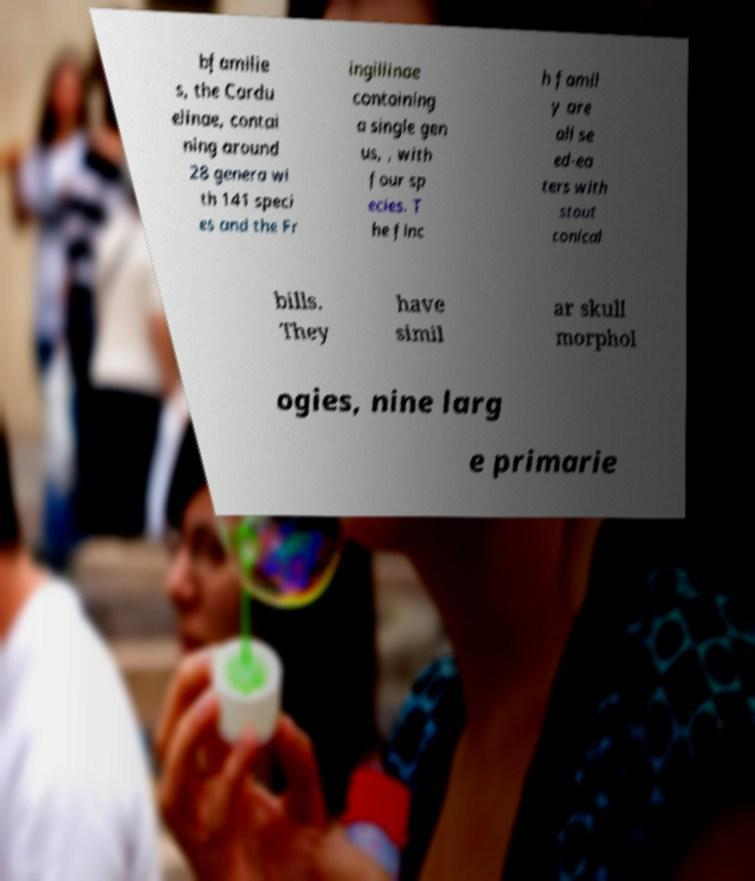Can you accurately transcribe the text from the provided image for me? bfamilie s, the Cardu elinae, contai ning around 28 genera wi th 141 speci es and the Fr ingillinae containing a single gen us, , with four sp ecies. T he finc h famil y are all se ed-ea ters with stout conical bills. They have simil ar skull morphol ogies, nine larg e primarie 